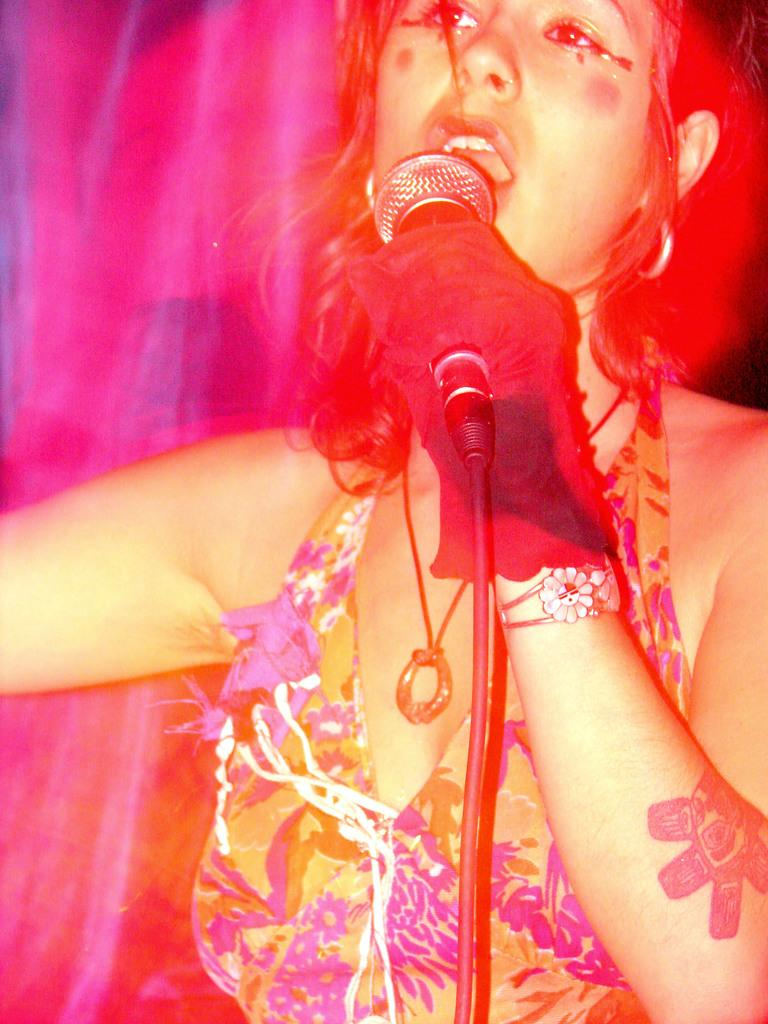Who is the main subject in the image? There is a woman in the image. What is the woman doing in the image? The woman is standing and singing a song. What is the woman using to amplify her voice? The woman is using a microphone. Is there any additional equipment related to the microphone in the image? Yes, there is a microphone stand in the image. What type of hole can be seen in the image? There is no hole present in the image. What does the woman believe in while singing the song? The image does not provide information about the woman's beliefs or the content of the song she is singing. 